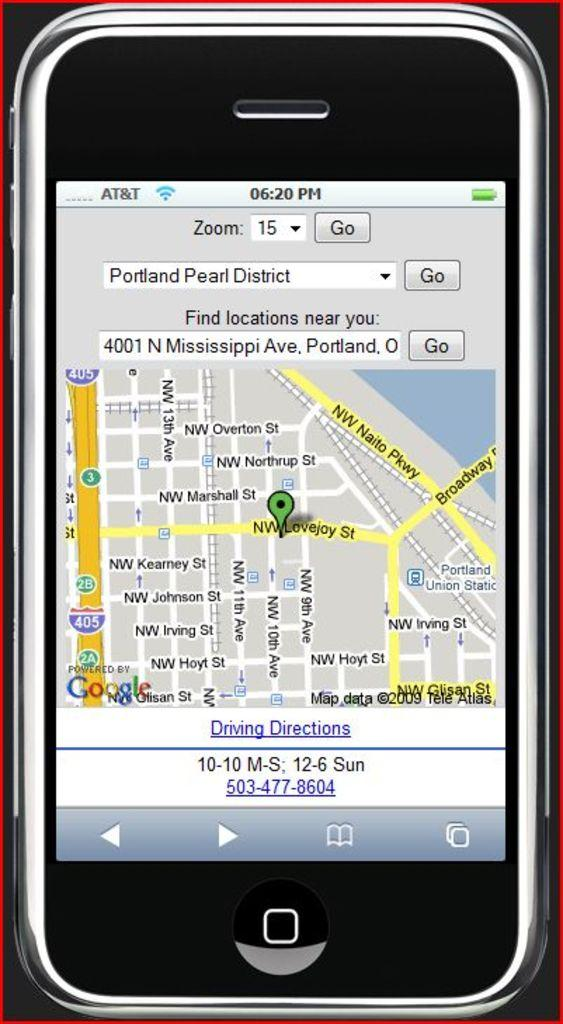<image>
Describe the image concisely. A smartphone is open to a map of Portland Pearl District and it is 6:20 pm. 